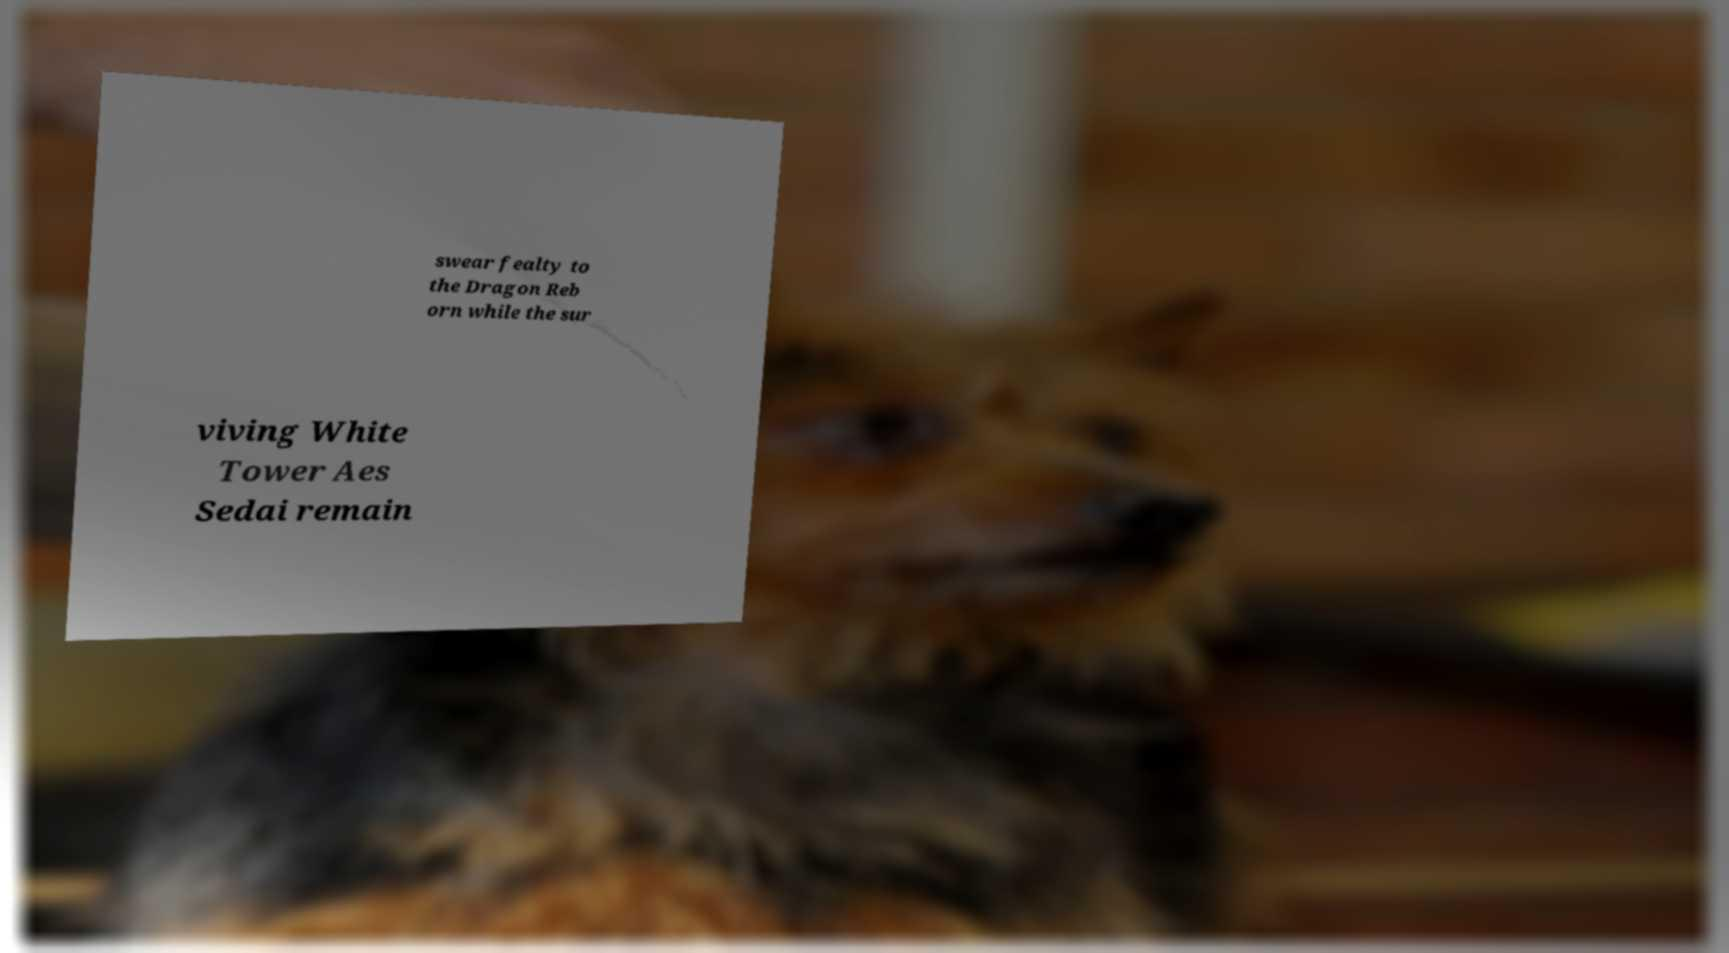Can you accurately transcribe the text from the provided image for me? swear fealty to the Dragon Reb orn while the sur viving White Tower Aes Sedai remain 